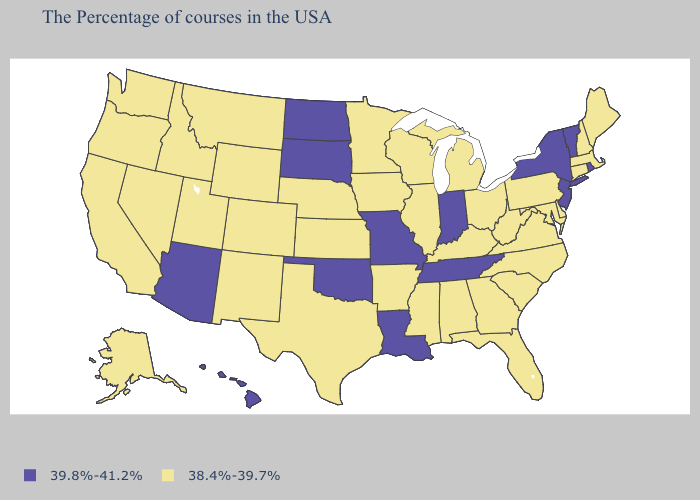What is the lowest value in the South?
Concise answer only. 38.4%-39.7%. Does Delaware have the highest value in the South?
Write a very short answer. No. Is the legend a continuous bar?
Answer briefly. No. What is the lowest value in the USA?
Give a very brief answer. 38.4%-39.7%. Name the states that have a value in the range 38.4%-39.7%?
Give a very brief answer. Maine, Massachusetts, New Hampshire, Connecticut, Delaware, Maryland, Pennsylvania, Virginia, North Carolina, South Carolina, West Virginia, Ohio, Florida, Georgia, Michigan, Kentucky, Alabama, Wisconsin, Illinois, Mississippi, Arkansas, Minnesota, Iowa, Kansas, Nebraska, Texas, Wyoming, Colorado, New Mexico, Utah, Montana, Idaho, Nevada, California, Washington, Oregon, Alaska. What is the value of Massachusetts?
Be succinct. 38.4%-39.7%. Does Pennsylvania have the lowest value in the Northeast?
Give a very brief answer. Yes. Which states hav the highest value in the MidWest?
Short answer required. Indiana, Missouri, South Dakota, North Dakota. What is the highest value in states that border Maryland?
Quick response, please. 38.4%-39.7%. Name the states that have a value in the range 38.4%-39.7%?
Give a very brief answer. Maine, Massachusetts, New Hampshire, Connecticut, Delaware, Maryland, Pennsylvania, Virginia, North Carolina, South Carolina, West Virginia, Ohio, Florida, Georgia, Michigan, Kentucky, Alabama, Wisconsin, Illinois, Mississippi, Arkansas, Minnesota, Iowa, Kansas, Nebraska, Texas, Wyoming, Colorado, New Mexico, Utah, Montana, Idaho, Nevada, California, Washington, Oregon, Alaska. Does Virginia have the highest value in the South?
Write a very short answer. No. Does Hawaii have the lowest value in the USA?
Give a very brief answer. No. Name the states that have a value in the range 39.8%-41.2%?
Give a very brief answer. Rhode Island, Vermont, New York, New Jersey, Indiana, Tennessee, Louisiana, Missouri, Oklahoma, South Dakota, North Dakota, Arizona, Hawaii. What is the value of Minnesota?
Keep it brief. 38.4%-39.7%. What is the lowest value in the USA?
Short answer required. 38.4%-39.7%. 